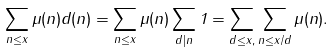<formula> <loc_0><loc_0><loc_500><loc_500>\sum _ { n \leq x } \mu ( n ) d ( n ) = \sum _ { n \leq x } \mu ( n ) \sum _ { d | n } 1 = \sum _ { d \leq x , } \sum _ { n \leq x / d } \mu ( n ) .</formula> 